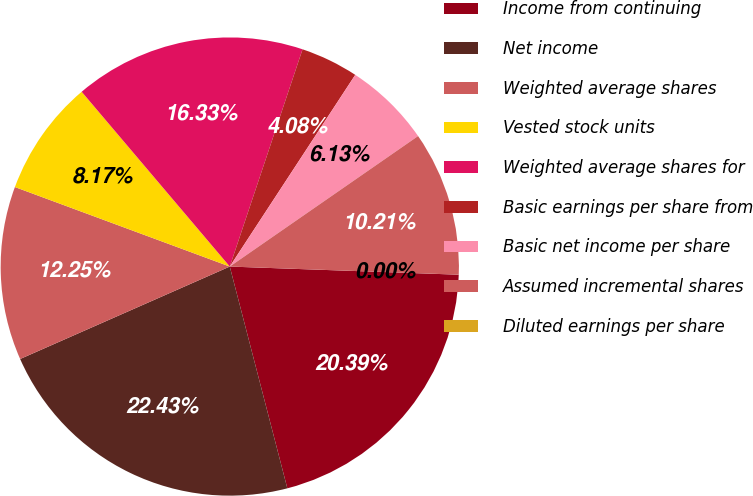Convert chart. <chart><loc_0><loc_0><loc_500><loc_500><pie_chart><fcel>Income from continuing<fcel>Net income<fcel>Weighted average shares<fcel>Vested stock units<fcel>Weighted average shares for<fcel>Basic earnings per share from<fcel>Basic net income per share<fcel>Assumed incremental shares<fcel>Diluted earnings per share<nl><fcel>20.39%<fcel>22.43%<fcel>12.25%<fcel>8.17%<fcel>16.33%<fcel>4.08%<fcel>6.13%<fcel>10.21%<fcel>0.0%<nl></chart> 